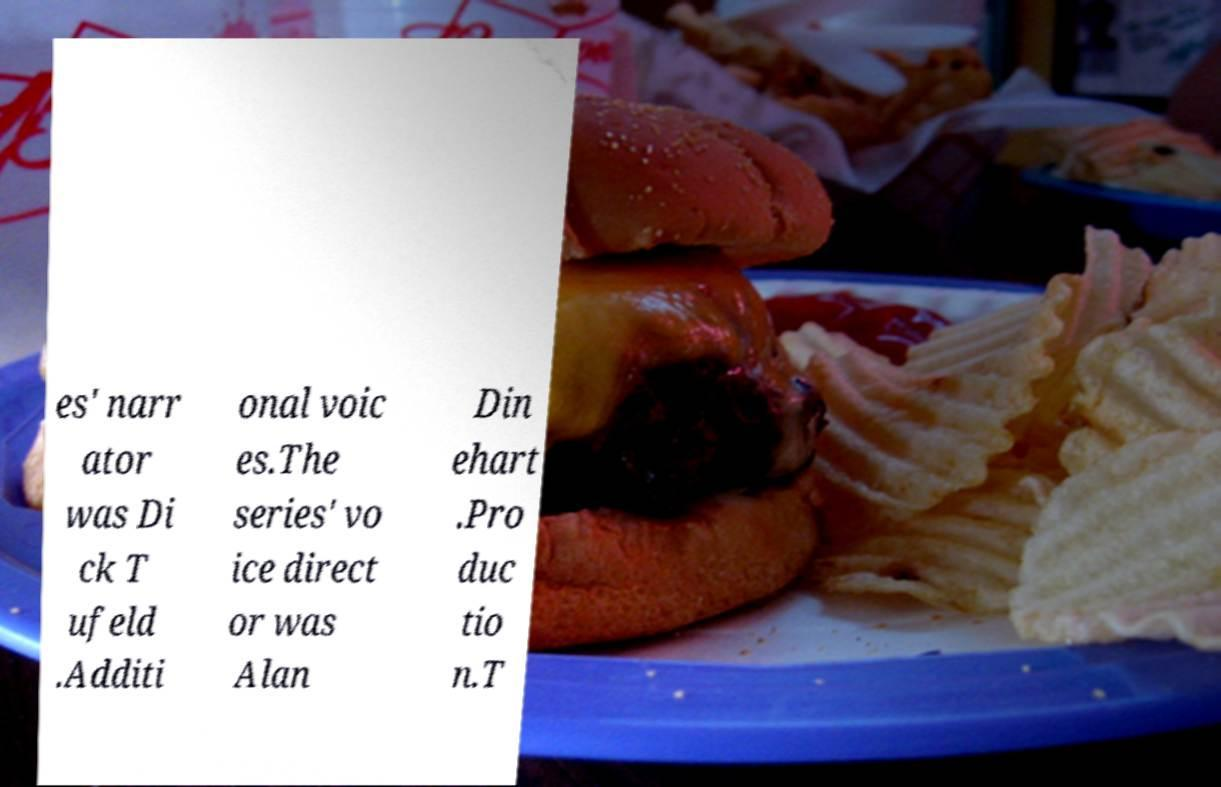I need the written content from this picture converted into text. Can you do that? es' narr ator was Di ck T ufeld .Additi onal voic es.The series' vo ice direct or was Alan Din ehart .Pro duc tio n.T 